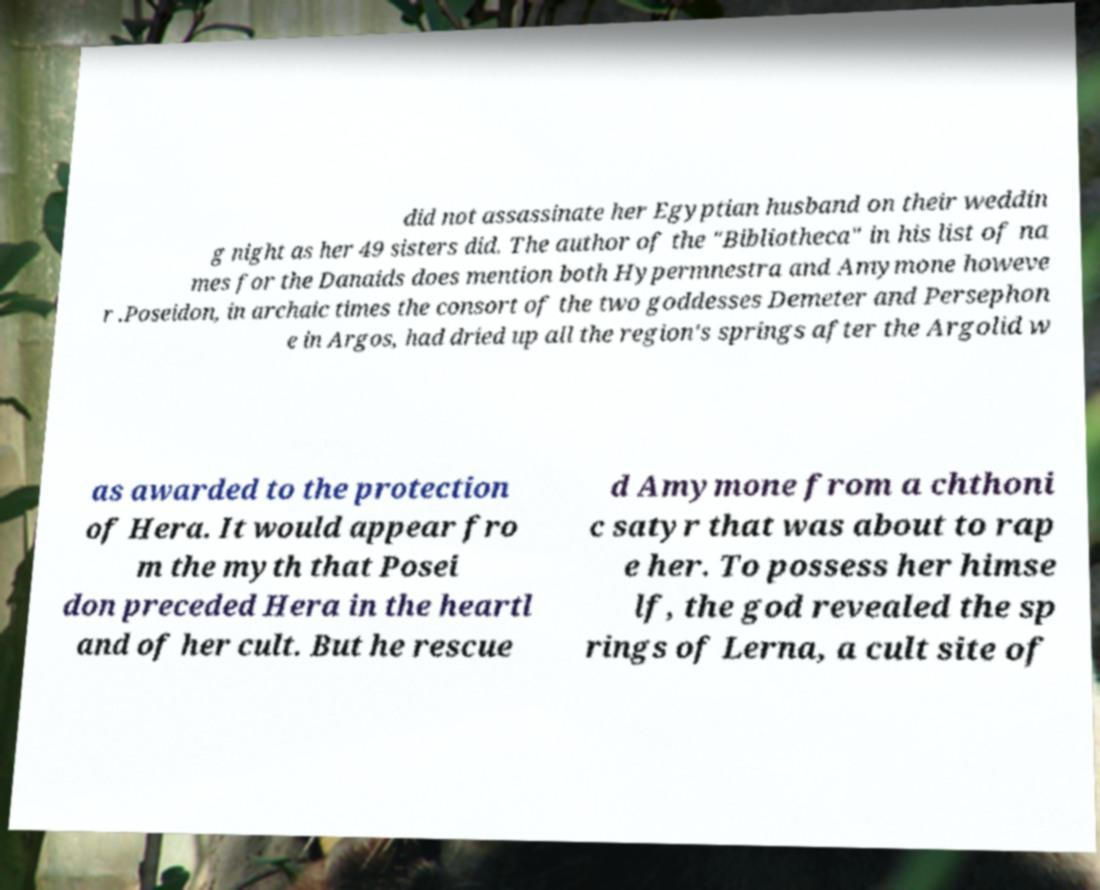I need the written content from this picture converted into text. Can you do that? did not assassinate her Egyptian husband on their weddin g night as her 49 sisters did. The author of the "Bibliotheca" in his list of na mes for the Danaids does mention both Hypermnestra and Amymone howeve r .Poseidon, in archaic times the consort of the two goddesses Demeter and Persephon e in Argos, had dried up all the region's springs after the Argolid w as awarded to the protection of Hera. It would appear fro m the myth that Posei don preceded Hera in the heartl and of her cult. But he rescue d Amymone from a chthoni c satyr that was about to rap e her. To possess her himse lf, the god revealed the sp rings of Lerna, a cult site of 